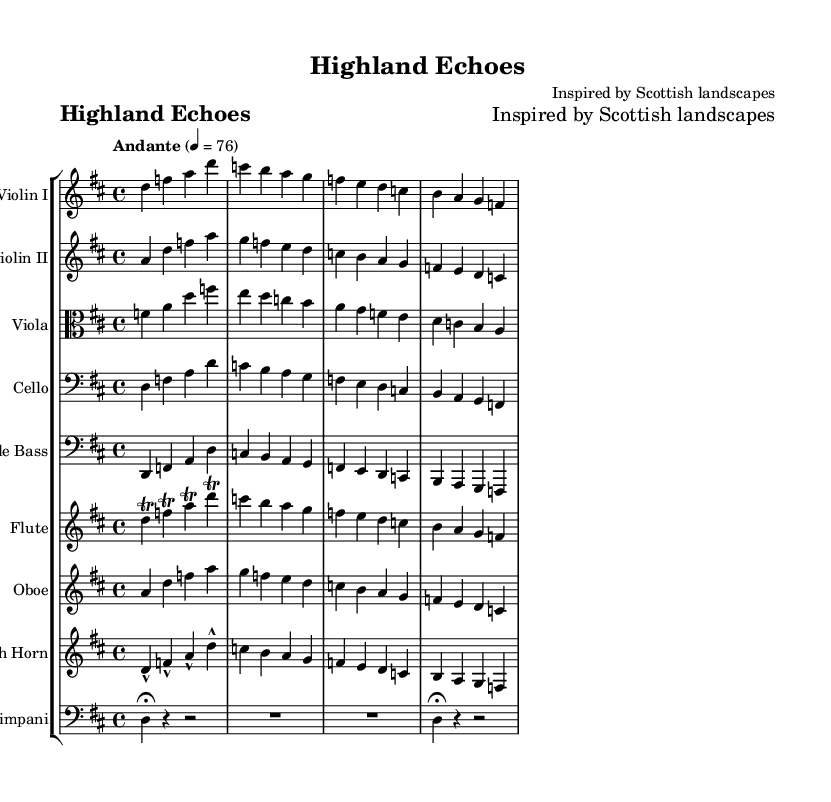What is the title of this piece? The title is found in the header information of the sheet music, which reads "Highland Echoes."
Answer: Highland Echoes What is the key signature of this music? The key signature is indicated at the beginning of the score, showing two sharps. This corresponds to the key of D major.
Answer: D major What is the time signature of this piece? The time signature is located next to the clef at the beginning of the music, which shows 4/4, meaning there are four beats per measure.
Answer: 4/4 What is the tempo indication for this piece? The tempo marking is found alongside the time signature and states "Andante," with a metronome marking of ♩ = 76, suggesting a moderate pace.
Answer: Andante Which instruments are included in the orchestration? The orchestration is listed in the score layout, which includes violin I, violin II, viola, cello, double bass, flute, oboe, French horn, and timpani.
Answer: Violin I, Violin II, Viola, Cello, Double Bass, Flute, Oboe, French Horn, Timpani What are two notable musical techniques found in the flute part? The flute part features trills on several notes, indicated by the notation. This embellishment enhances the piece's expressiveness, representing the lively nature of traditional Scottish melodies.
Answer: Trills How many measures are there in the main theme for the strings? To find the number of measures, one can count the musical groupings for the strings. In this case, there are four measures for each instrument, indicating a unified main theme.
Answer: Four 